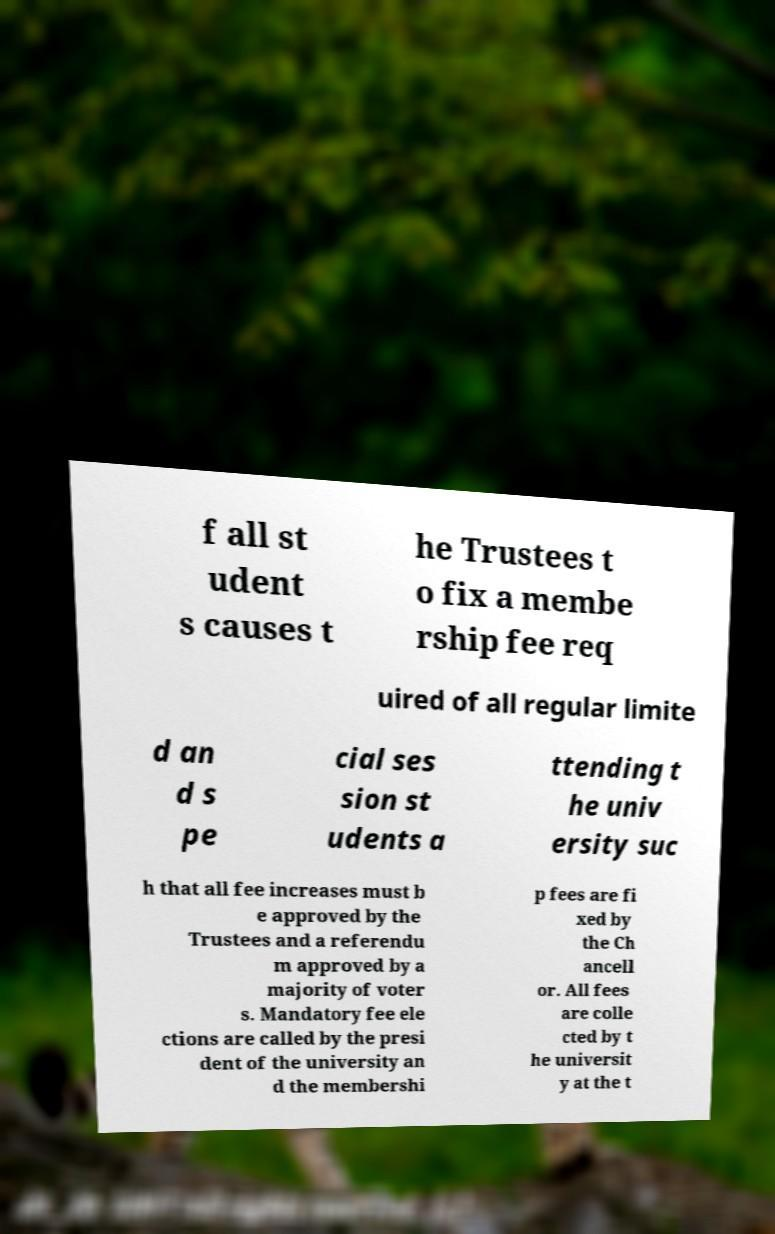For documentation purposes, I need the text within this image transcribed. Could you provide that? f all st udent s causes t he Trustees t o fix a membe rship fee req uired of all regular limite d an d s pe cial ses sion st udents a ttending t he univ ersity suc h that all fee increases must b e approved by the Trustees and a referendu m approved by a majority of voter s. Mandatory fee ele ctions are called by the presi dent of the university an d the membershi p fees are fi xed by the Ch ancell or. All fees are colle cted by t he universit y at the t 